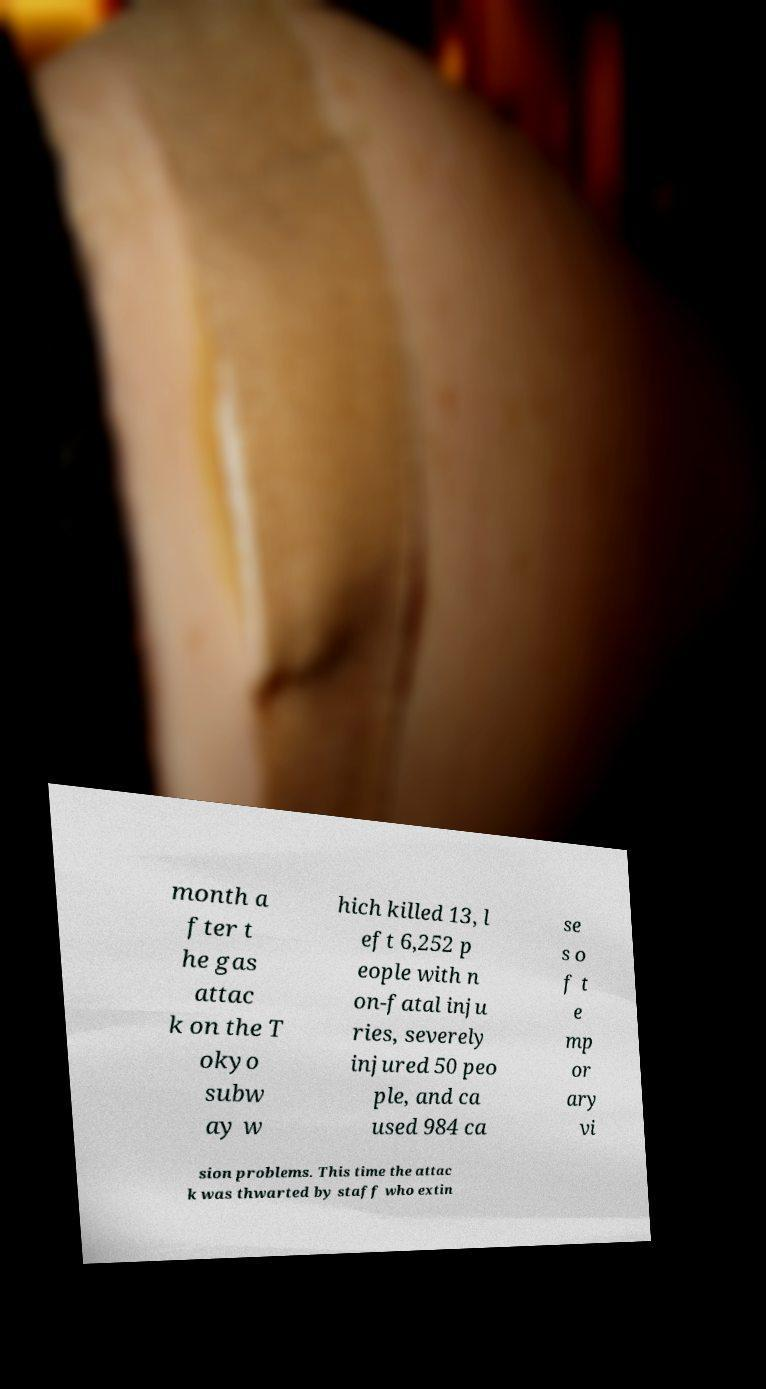What messages or text are displayed in this image? I need them in a readable, typed format. month a fter t he gas attac k on the T okyo subw ay w hich killed 13, l eft 6,252 p eople with n on-fatal inju ries, severely injured 50 peo ple, and ca used 984 ca se s o f t e mp or ary vi sion problems. This time the attac k was thwarted by staff who extin 